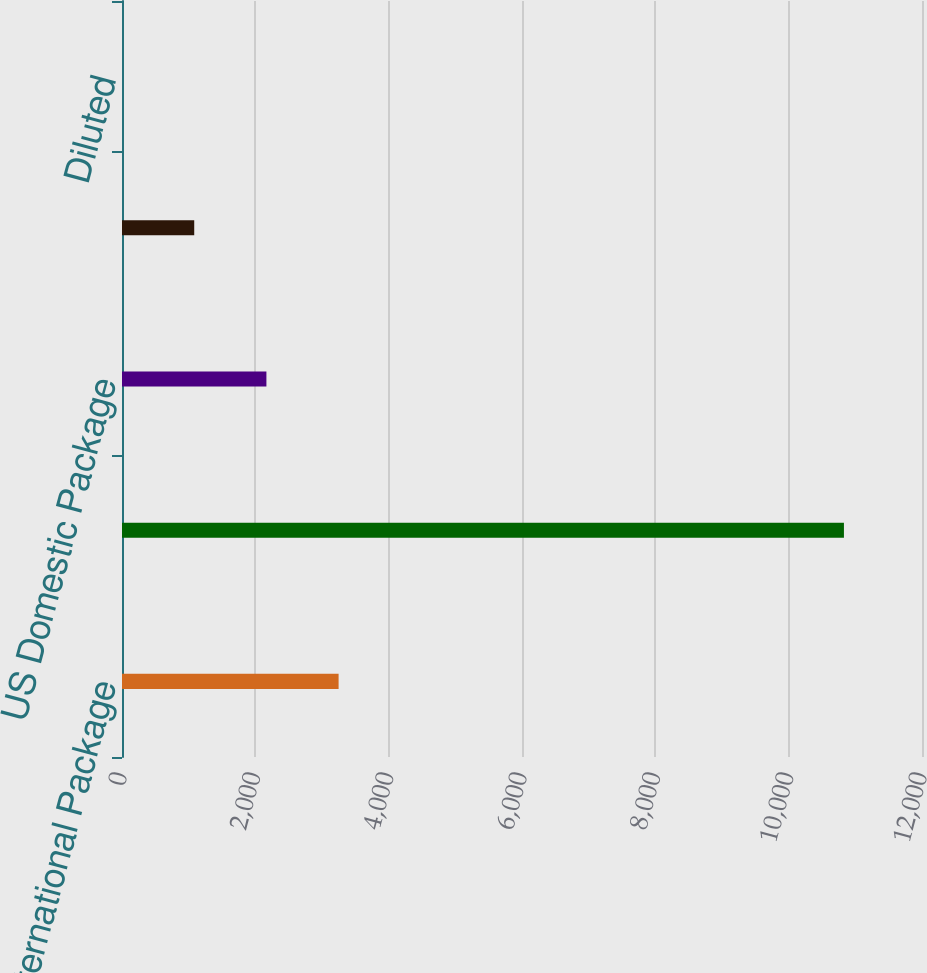Convert chart. <chart><loc_0><loc_0><loc_500><loc_500><bar_chart><fcel>International Package<fcel>Total revenue<fcel>US Domestic Package<fcel>Basic<fcel>Diluted<nl><fcel>3249.02<fcel>10829<fcel>2166.16<fcel>1083.3<fcel>0.44<nl></chart> 